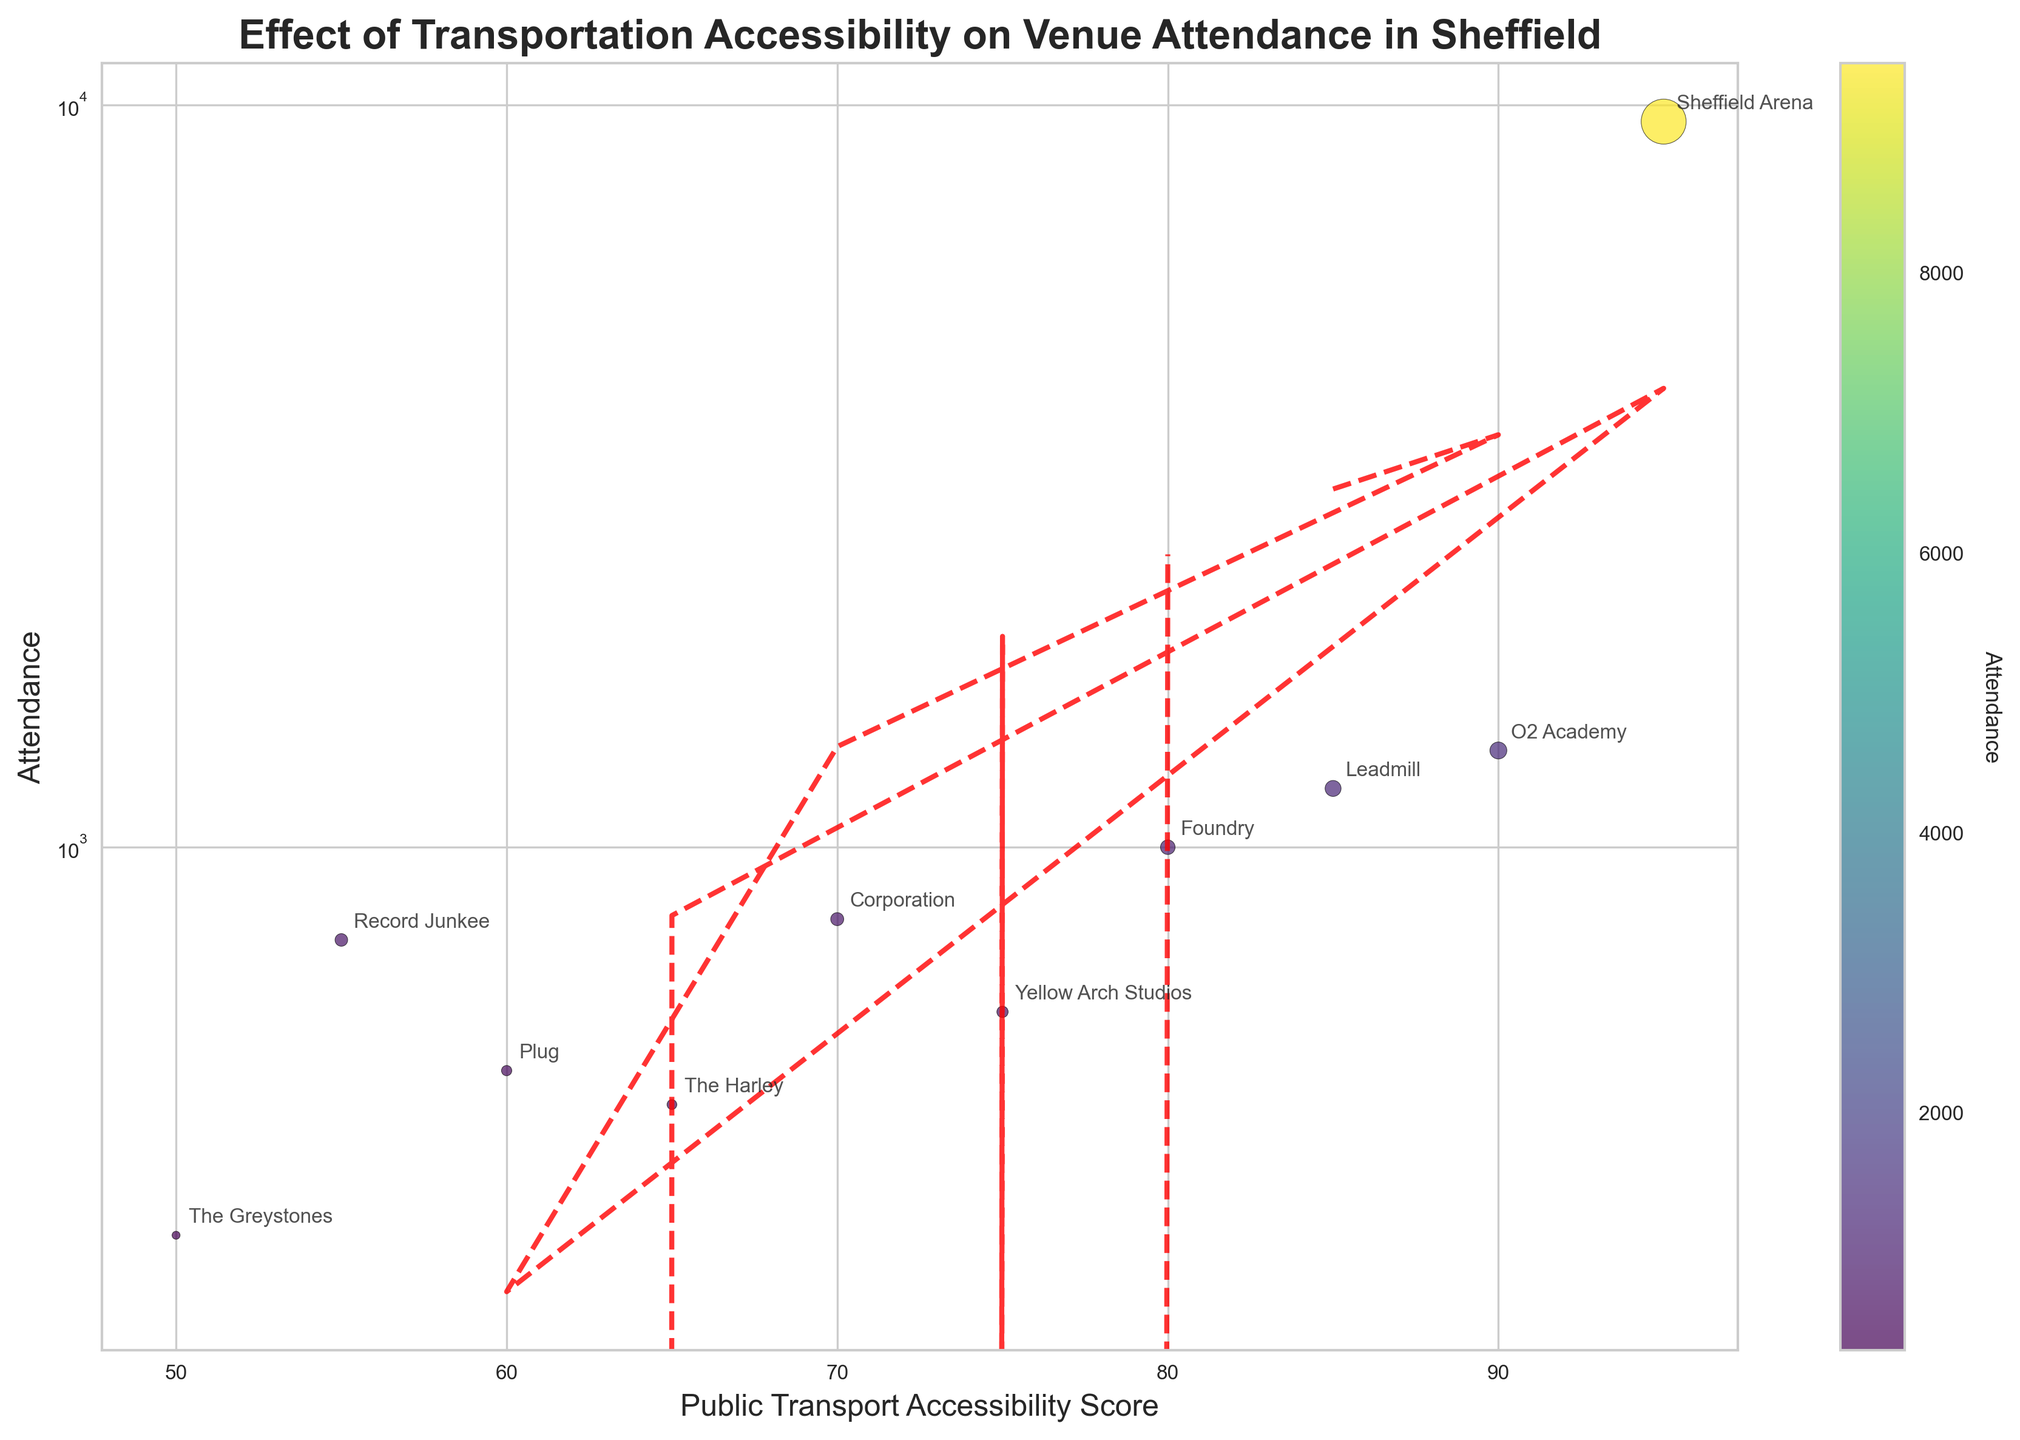How many venues are plotted in the figure? The figure shows 10 data points, and each data point represents one venue. The scatter plot includes annotations for each venue, allowing us to count and identify them.
Answer: 10 What is the venue with the highest attendance and what is its public transport accessibility score? The venue with the highest attendance is Sheffield Arena, with an attendance of 9500. The public transport accessibility score for Sheffield Arena is 95, which can be seen from the annotated point on the scatter plot.
Answer: Sheffield Arena, 95 Compare Leadmill and The Greystones: Which has a higher public transport accessibility score and what is the difference in their attendance? Leadmill has a higher public transport accessibility score of 85 compared to The Greystones' score of 50. In terms of attendance, Leadmill has 1200, while The Greystones has 300. The difference in their attendance is 1200 - 300 = 900.
Answer: Leadmill, 900 How does attendance vary with public transport accessibility according to the trend line? The trend line on the scatter plot shows a positive correlation, indicating that as the public transport accessibility score increases, the attendance at the music venues generally increases as well. This is visually evident from the upward slope of the trend line.
Answer: Increases Which venue has the lowest public transport accessibility score and what is its attendance? The venue with the lowest public transport accessibility score is The Greystones, with a score of 50. Its attendance is 300 as annotated on the scatter plot.
Answer: The Greystones, 300 Identify the venue with the second highest attendance and compare its public transport accessibility score to the average score of all venues. The venue with the second highest attendance is O2 Academy with an attendance of 1350. To find the average public transport accessibility score, sum all scores (85+90+70+60+95+65+55+75+50+80) and divide by 10, which equals 72.5. O2 Academy's score is 90, which is higher than the average score of 72.5.
Answer: O2 Academy, higher than average Do any two venues have the same attendance? If so, which ones and what is their public transport accessibility score? No two venues have the same attendance. From the scatter plot and attendance annotations, each venue has a unique attendance figure.
Answer: No Which venue with a public transport accessibility score less than 70 has the highest attendance? Among venues with a public transport accessibility score less than 70, Corporation has the highest attendance of 800. The relevant scores and attendance for such venues are directly visible from the scatter plot annotations.
Answer: Corporation What trend does the red dashed line in the plot represent? The red dashed line represents the trend line, which indicates the overall trend or relationship between public transport accessibility score and attendance. It shows a positive correlation, meaning as public transport accessibility increases, attendance generally increases.
Answer: Positive correlation trend 